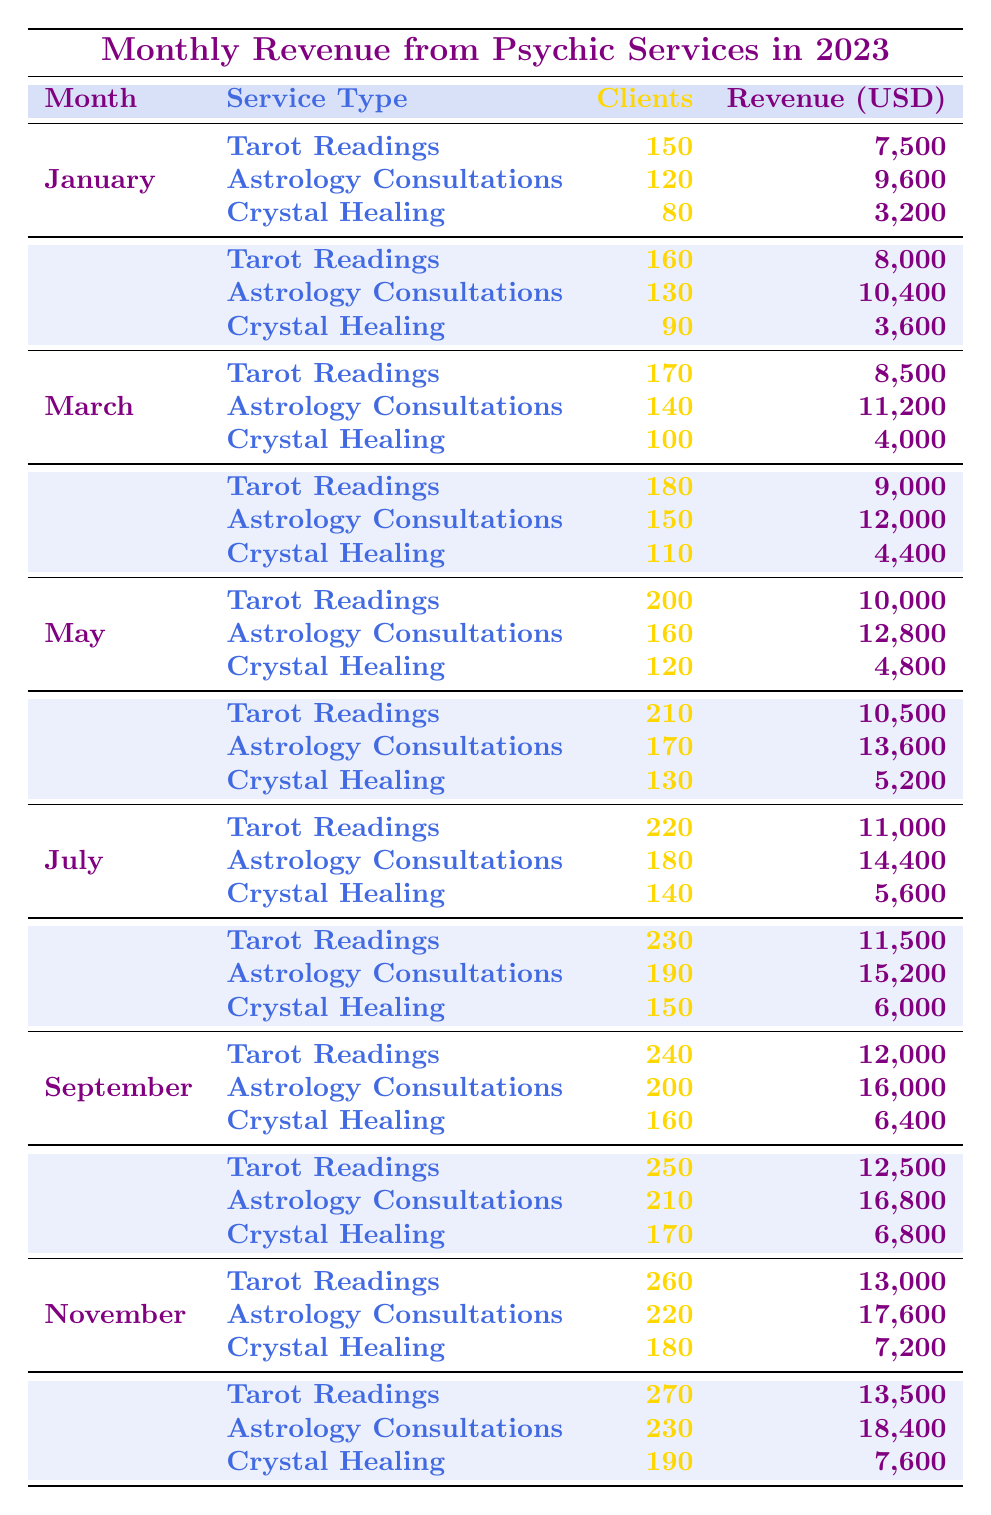What was the total revenue from Astrology Consultations in July? In July, the revenue from Astrology Consultations is listed as 14,400 USD. So, the total revenue is 14,400 USD.
Answer: 14,400 USD Which service generated the highest revenue in December? In December, Tarot Readings generated 13,500 USD, Astrology Consultations generated 18,400 USD, and Crystal Healing generated 7,600 USD. Therefore, the highest revenue was from Astrology Consultations.
Answer: Astrology Consultations What is the average revenue from Crystal Healing for the year? The revenues from Crystal Healing each month are: 3,200, 3,600, 4,000, 4,400, 4,800, 5,200, 5,600, 6,000, 6,400, 6,800, 7,200, and 7,600 USD. Adding these values gives 57,600 USD. Since there are 12 months, the average revenue is 57,600 / 12 = 4,800 USD.
Answer: 4,800 USD Did more than 200 clients use Tarot Readings in August? In August, the clients served for Tarot Readings is 230. Since 230 is greater than 200, the statement is true.
Answer: Yes What was the cumulative revenue from Tarot Readings across the first six months? For the first six months, the revenues from Tarot Readings are: 7,500, 8,000, 8,500, 9,000, 10,000, and 10,500 USD. Summing these gives 53,500 USD.
Answer: 53,500 USD Which month had the highest total number of clients across all service types? The total clients per month are: January (350), February (380), March (410), April (440), May (480), June (510), July (540), August (570), September (600), October (630), November (660), and December (690). December had the highest total with 690 clients.
Answer: December How much more revenue did Astrology Consultations make in September compared to January? In January, the revenue from Astrology Consultations is 9,600 USD, and in September it is 16,000 USD. The difference is 16,000 - 9,600 = 6,400 USD.
Answer: 6,400 USD What is the total number of clients served for Crystal Healing in the first half of the year? The clients served for Crystal Healing from January to June are: 80, 90, 100, 110, 120, and 130. Adding these gives 80 + 90 + 100 + 110 + 120 + 130 = 630 clients.
Answer: 630 clients Was there any month where the revenue from Tarot Readings was less than 10,000 USD? The revenues from Tarot Readings are: 7,500 (January), 8,000 (February), 8,500 (March), 9,000 (April), and 10,000 (May). Since January, February, and March have revenues below 10,000 USD, the answer is yes.
Answer: Yes In which month did the highest number of clients visit for Astrology Consultations? The number of clients served for Astrology Consultations peaked in December at 230 clients.
Answer: December 